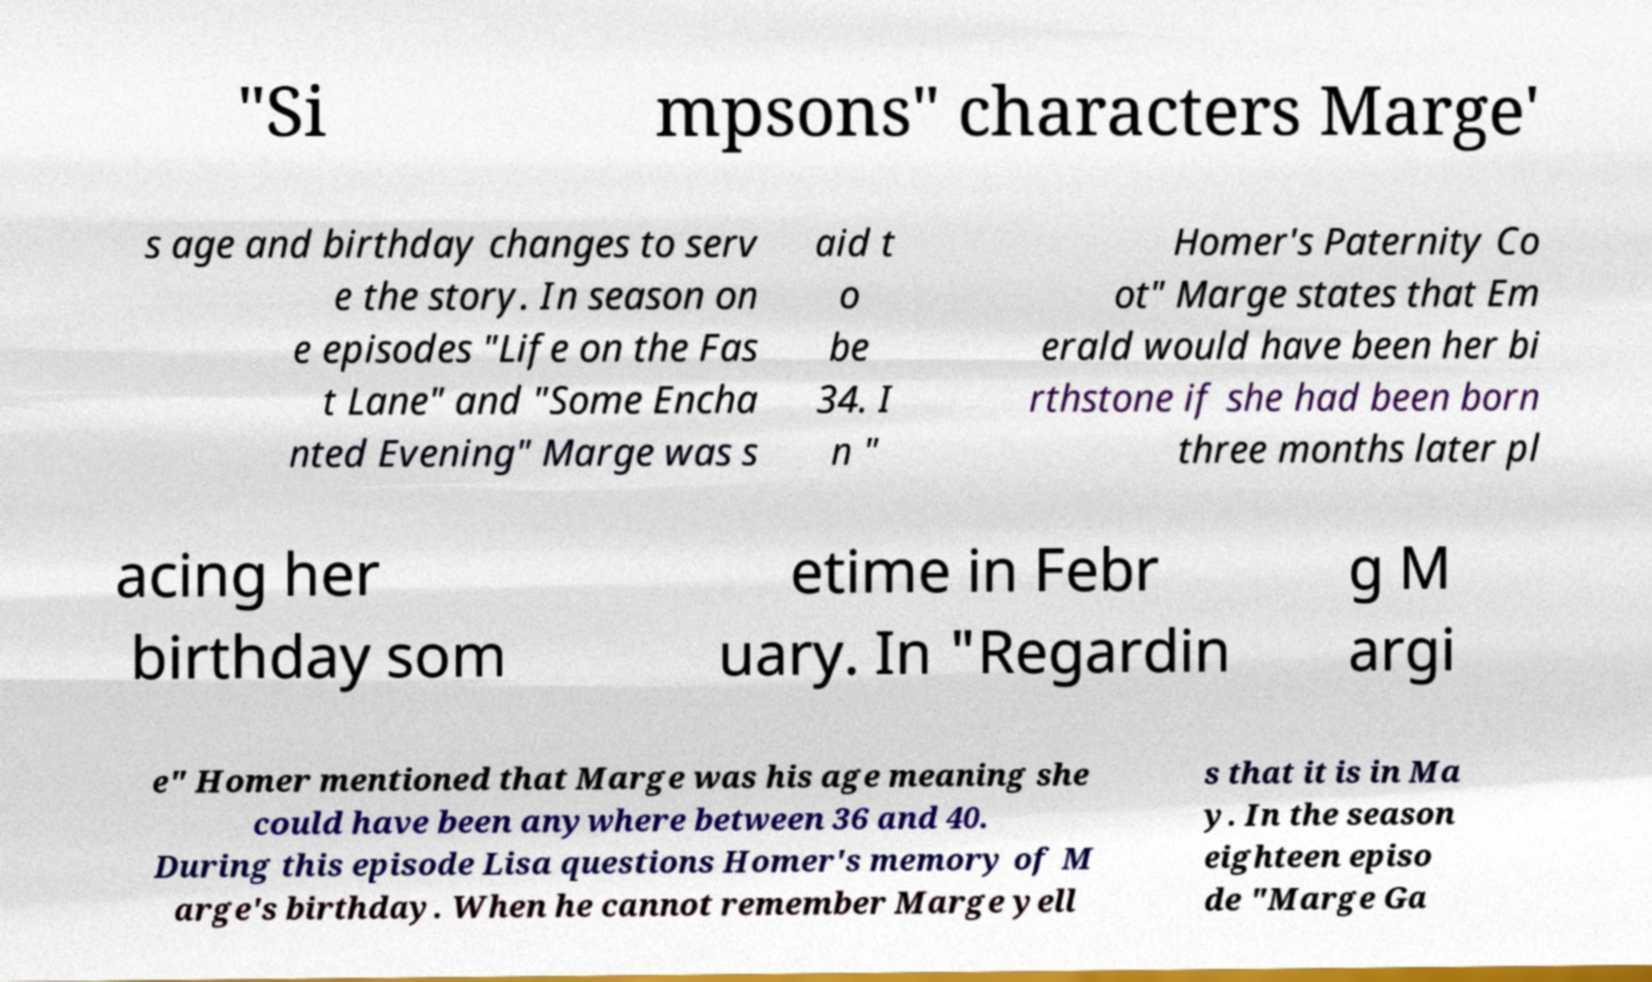For documentation purposes, I need the text within this image transcribed. Could you provide that? "Si mpsons" characters Marge' s age and birthday changes to serv e the story. In season on e episodes "Life on the Fas t Lane" and "Some Encha nted Evening" Marge was s aid t o be 34. I n " Homer's Paternity Co ot" Marge states that Em erald would have been her bi rthstone if she had been born three months later pl acing her birthday som etime in Febr uary. In "Regardin g M argi e" Homer mentioned that Marge was his age meaning she could have been anywhere between 36 and 40. During this episode Lisa questions Homer's memory of M arge's birthday. When he cannot remember Marge yell s that it is in Ma y. In the season eighteen episo de "Marge Ga 